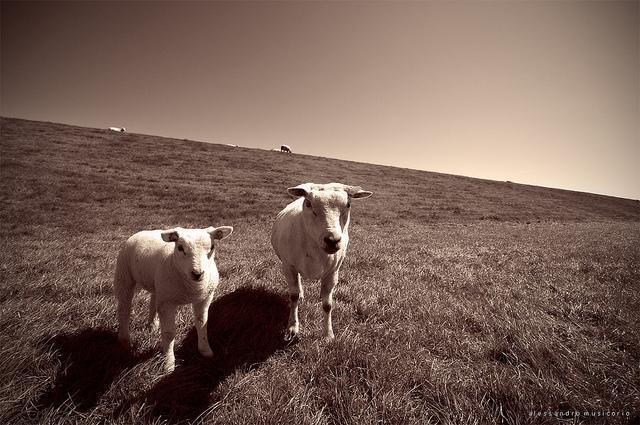How many animals are in this photo?
Give a very brief answer. 4. How many sheep are visible?
Give a very brief answer. 2. How many birds are in the picture?
Give a very brief answer. 0. 